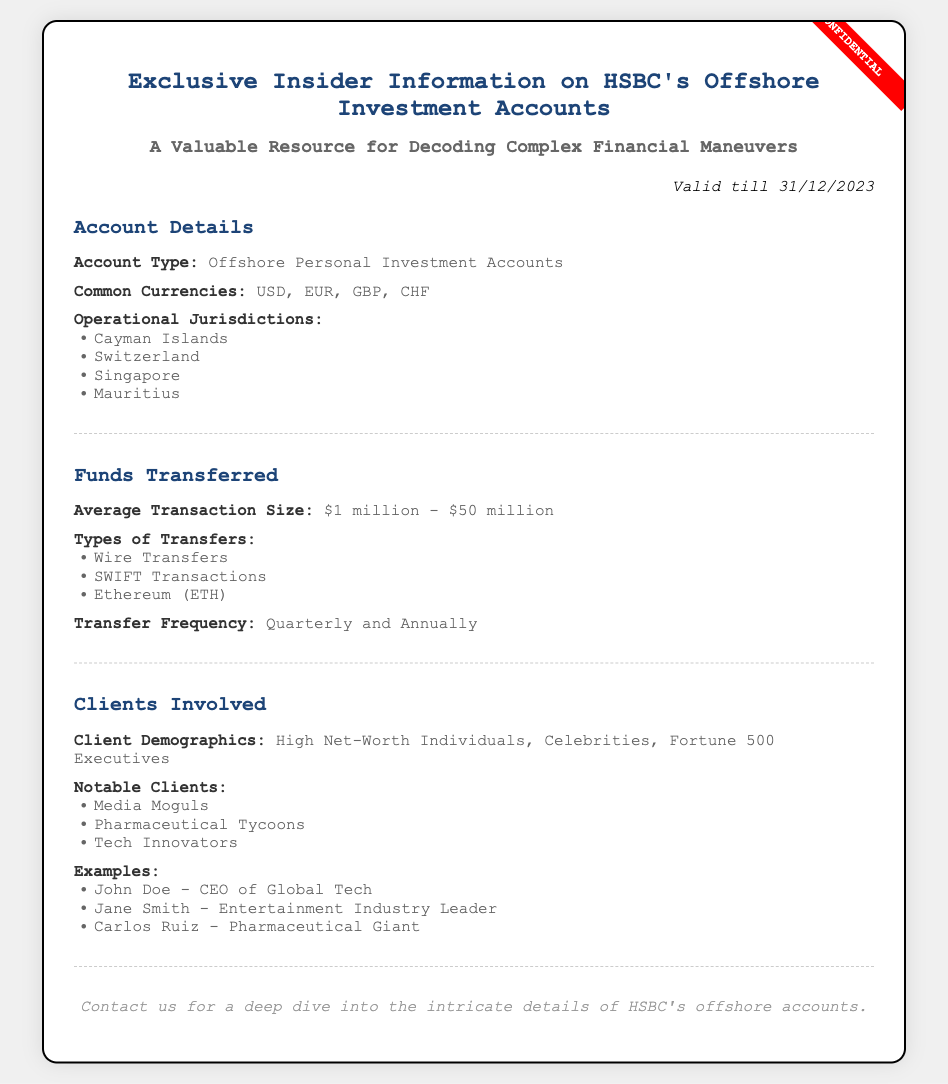what type of accounts are mentioned? The document specifies that the accounts are Offshore Personal Investment Accounts.
Answer: Offshore Personal Investment Accounts which currencies are commonly used? The document lists the common currencies used for the accounts, including USD, EUR, GBP, and CHF.
Answer: USD, EUR, GBP, CHF what is the average transaction size range? The average transaction size is indicated in the document, which is between $1 million and $50 million.
Answer: $1 million - $50 million how often do transfers occur? The document states the transfer frequency for the accounts is quarterly and annually.
Answer: Quarterly and Annually who are the notable clients mentioned? The document lists several notable clients, which includes Media Moguls, Pharmaceutical Tycoons, and Tech Innovators.
Answer: Media Moguls, Pharmaceutical Tycoons, Tech Innovators what is the validity period of this voucher? The validity period of the voucher is specified in the document as valid till 31/12/2023.
Answer: 31/12/2023 what types of transfers are listed? The document lists Wire Transfers, SWIFT Transactions, and Ethereum as the types of transfers.
Answer: Wire Transfers, SWIFT Transactions, Ethereum who is the CEO of Global Tech? The document provides an example of a client, where John Doe is identified as the CEO of Global Tech.
Answer: John Doe which operational jurisdictions are mentioned? The document identifies the Cayman Islands, Switzerland, Singapore, and Mauritius as operational jurisdictions.
Answer: Cayman Islands, Switzerland, Singapore, Mauritius 